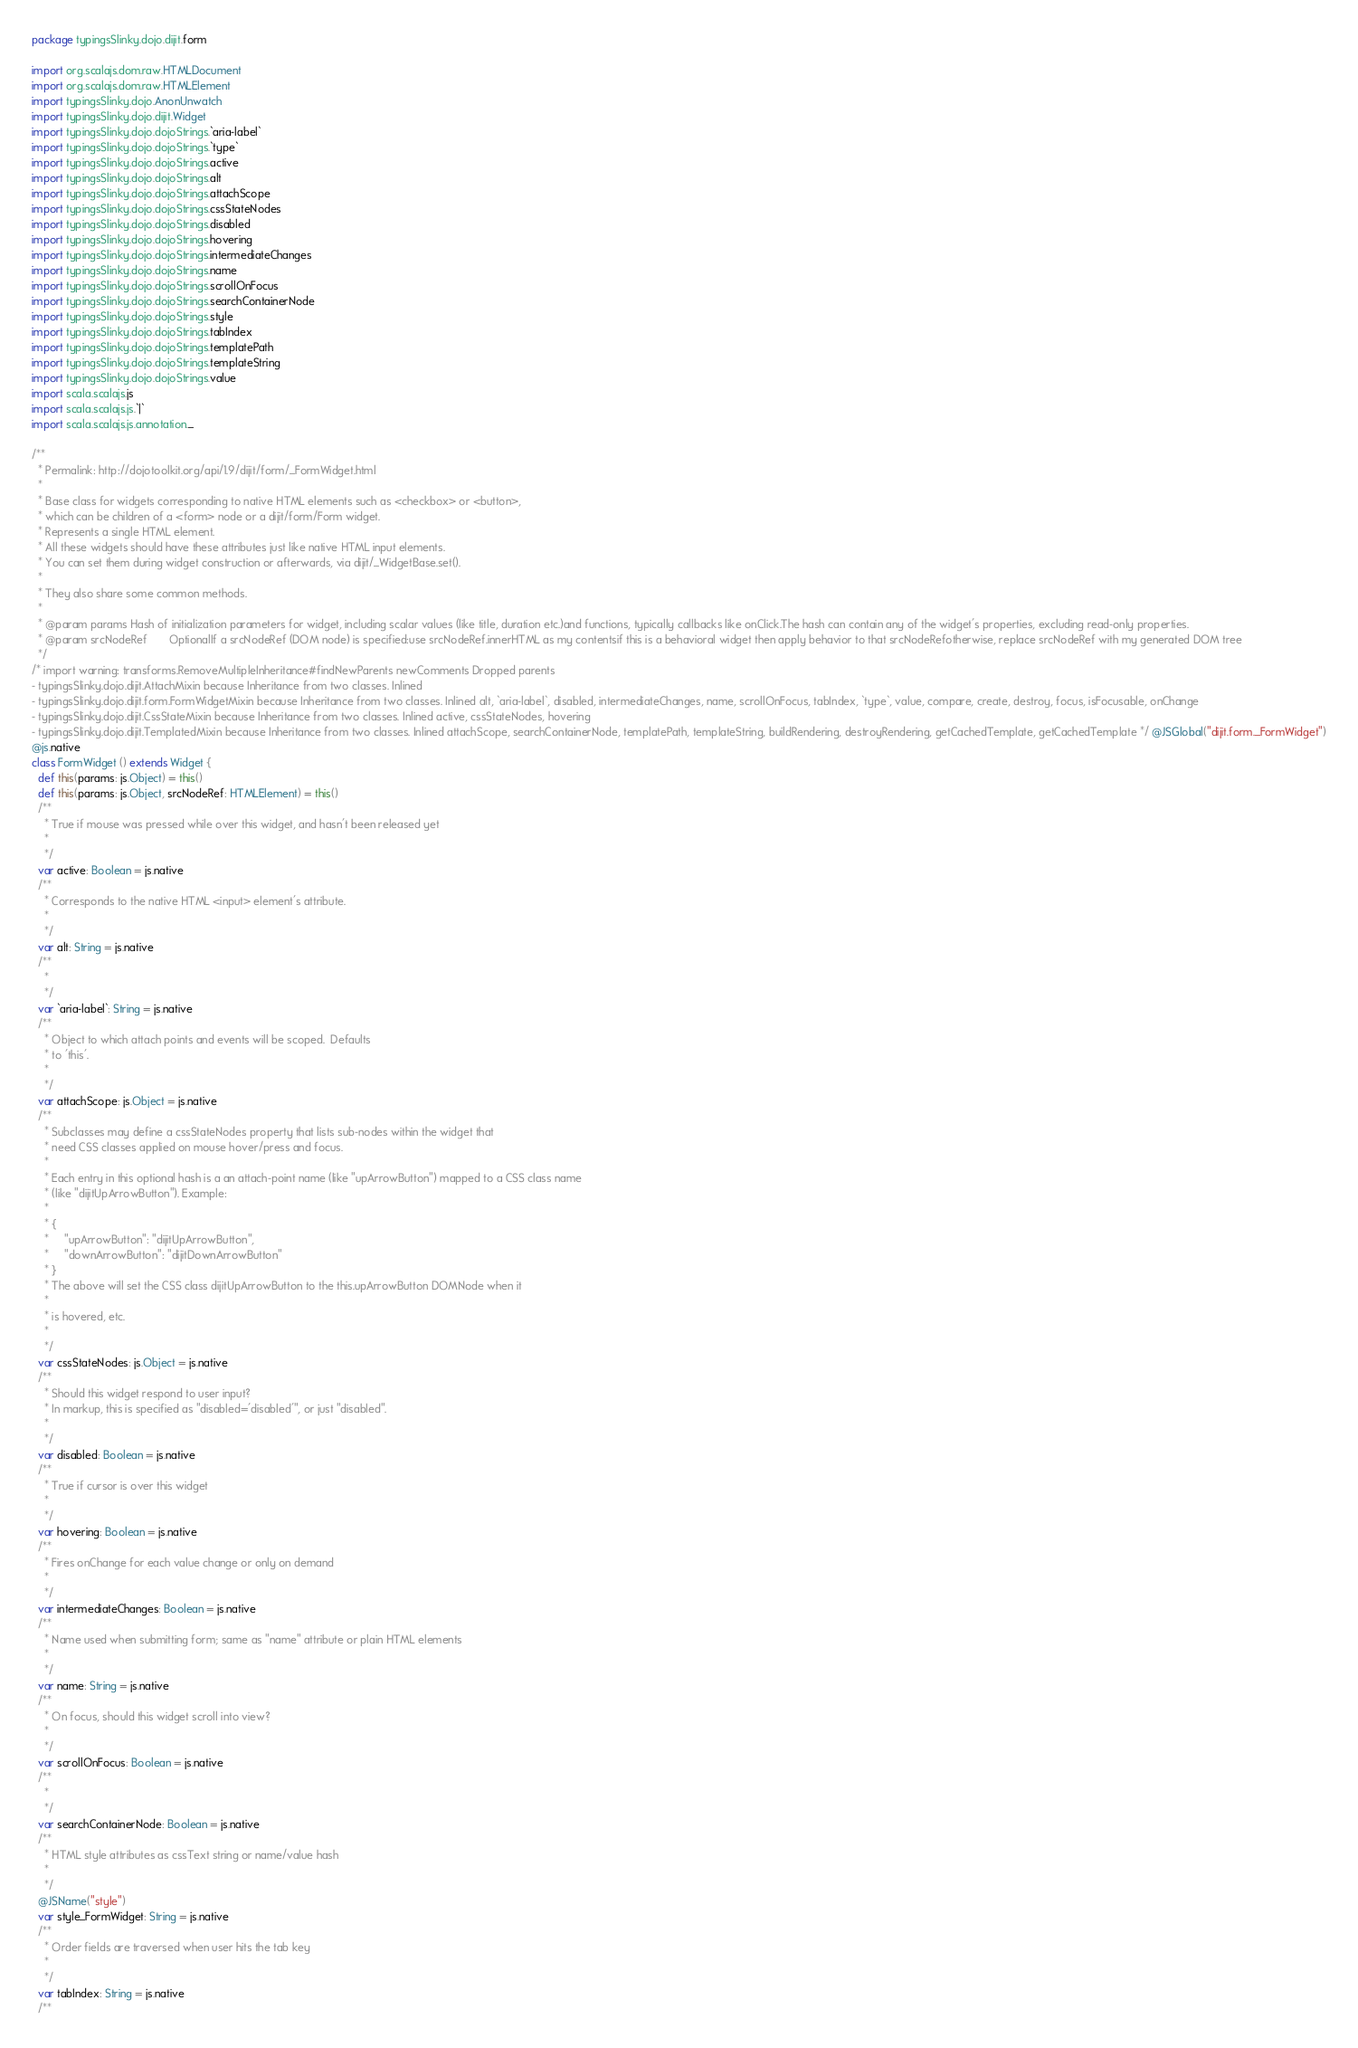<code> <loc_0><loc_0><loc_500><loc_500><_Scala_>package typingsSlinky.dojo.dijit.form

import org.scalajs.dom.raw.HTMLDocument
import org.scalajs.dom.raw.HTMLElement
import typingsSlinky.dojo.AnonUnwatch
import typingsSlinky.dojo.dijit.Widget
import typingsSlinky.dojo.dojoStrings.`aria-label`
import typingsSlinky.dojo.dojoStrings.`type`
import typingsSlinky.dojo.dojoStrings.active
import typingsSlinky.dojo.dojoStrings.alt
import typingsSlinky.dojo.dojoStrings.attachScope
import typingsSlinky.dojo.dojoStrings.cssStateNodes
import typingsSlinky.dojo.dojoStrings.disabled
import typingsSlinky.dojo.dojoStrings.hovering
import typingsSlinky.dojo.dojoStrings.intermediateChanges
import typingsSlinky.dojo.dojoStrings.name
import typingsSlinky.dojo.dojoStrings.scrollOnFocus
import typingsSlinky.dojo.dojoStrings.searchContainerNode
import typingsSlinky.dojo.dojoStrings.style
import typingsSlinky.dojo.dojoStrings.tabIndex
import typingsSlinky.dojo.dojoStrings.templatePath
import typingsSlinky.dojo.dojoStrings.templateString
import typingsSlinky.dojo.dojoStrings.value
import scala.scalajs.js
import scala.scalajs.js.`|`
import scala.scalajs.js.annotation._

/**
  * Permalink: http://dojotoolkit.org/api/1.9/dijit/form/_FormWidget.html
  *
  * Base class for widgets corresponding to native HTML elements such as <checkbox> or <button>,
  * which can be children of a <form> node or a dijit/form/Form widget.
  * Represents a single HTML element.
  * All these widgets should have these attributes just like native HTML input elements.
  * You can set them during widget construction or afterwards, via dijit/_WidgetBase.set().
  * 
  * They also share some common methods.
  * 
  * @param params Hash of initialization parameters for widget, including scalar values (like title, duration etc.)and functions, typically callbacks like onClick.The hash can contain any of the widget's properties, excluding read-only properties.     
  * @param srcNodeRef       OptionalIf a srcNodeRef (DOM node) is specified:use srcNodeRef.innerHTML as my contentsif this is a behavioral widget then apply behavior to that srcNodeRefotherwise, replace srcNodeRef with my generated DOM tree     
  */
/* import warning: transforms.RemoveMultipleInheritance#findNewParents newComments Dropped parents 
- typingsSlinky.dojo.dijit.AttachMixin because Inheritance from two classes. Inlined 
- typingsSlinky.dojo.dijit.form.FormWidgetMixin because Inheritance from two classes. Inlined alt, `aria-label`, disabled, intermediateChanges, name, scrollOnFocus, tabIndex, `type`, value, compare, create, destroy, focus, isFocusable, onChange
- typingsSlinky.dojo.dijit.CssStateMixin because Inheritance from two classes. Inlined active, cssStateNodes, hovering
- typingsSlinky.dojo.dijit.TemplatedMixin because Inheritance from two classes. Inlined attachScope, searchContainerNode, templatePath, templateString, buildRendering, destroyRendering, getCachedTemplate, getCachedTemplate */ @JSGlobal("dijit.form._FormWidget")
@js.native
class FormWidget () extends Widget {
  def this(params: js.Object) = this()
  def this(params: js.Object, srcNodeRef: HTMLElement) = this()
  /**
    * True if mouse was pressed while over this widget, and hasn't been released yet
    * 
    */
  var active: Boolean = js.native
  /**
    * Corresponds to the native HTML <input> element's attribute.
    * 
    */
  var alt: String = js.native
  /**
    * 
    */
  var `aria-label`: String = js.native
  /**
    * Object to which attach points and events will be scoped.  Defaults
    * to 'this'.
    * 
    */
  var attachScope: js.Object = js.native
  /**
    * Subclasses may define a cssStateNodes property that lists sub-nodes within the widget that
    * need CSS classes applied on mouse hover/press and focus.
    * 
    * Each entry in this optional hash is a an attach-point name (like "upArrowButton") mapped to a CSS class name
    * (like "dijitUpArrowButton"). Example:
    * 
    * {
    *     "upArrowButton": "dijitUpArrowButton",
    *     "downArrowButton": "dijitDownArrowButton"
    * }
    * The above will set the CSS class dijitUpArrowButton to the this.upArrowButton DOMNode when it
    * 
    * is hovered, etc.
    * 
    */
  var cssStateNodes: js.Object = js.native
  /**
    * Should this widget respond to user input?
    * In markup, this is specified as "disabled='disabled'", or just "disabled".
    * 
    */
  var disabled: Boolean = js.native
  /**
    * True if cursor is over this widget
    * 
    */
  var hovering: Boolean = js.native
  /**
    * Fires onChange for each value change or only on demand
    * 
    */
  var intermediateChanges: Boolean = js.native
  /**
    * Name used when submitting form; same as "name" attribute or plain HTML elements
    * 
    */
  var name: String = js.native
  /**
    * On focus, should this widget scroll into view?
    * 
    */
  var scrollOnFocus: Boolean = js.native
  /**
    * 
    */
  var searchContainerNode: Boolean = js.native
  /**
    * HTML style attributes as cssText string or name/value hash
    * 
    */
  @JSName("style")
  var style_FormWidget: String = js.native
  /**
    * Order fields are traversed when user hits the tab key
    * 
    */
  var tabIndex: String = js.native
  /**</code> 